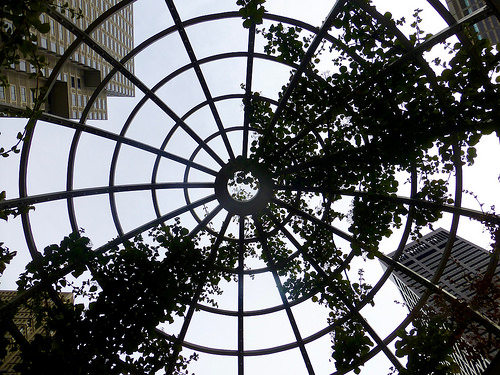<image>
Is the sky above the tree? Yes. The sky is positioned above the tree in the vertical space, higher up in the scene. 